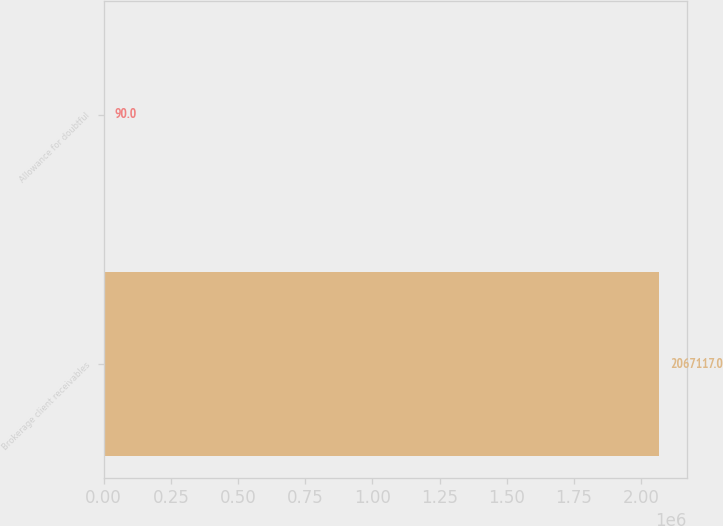<chart> <loc_0><loc_0><loc_500><loc_500><bar_chart><fcel>Brokerage client receivables<fcel>Allowance for doubtful<nl><fcel>2.06712e+06<fcel>90<nl></chart> 